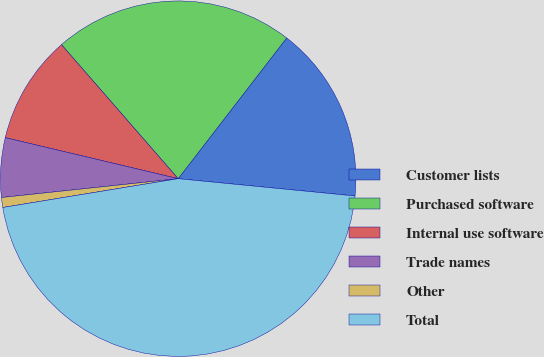Convert chart. <chart><loc_0><loc_0><loc_500><loc_500><pie_chart><fcel>Customer lists<fcel>Purchased software<fcel>Internal use software<fcel>Trade names<fcel>Other<fcel>Total<nl><fcel>16.1%<fcel>21.86%<fcel>9.89%<fcel>5.4%<fcel>0.9%<fcel>45.86%<nl></chart> 